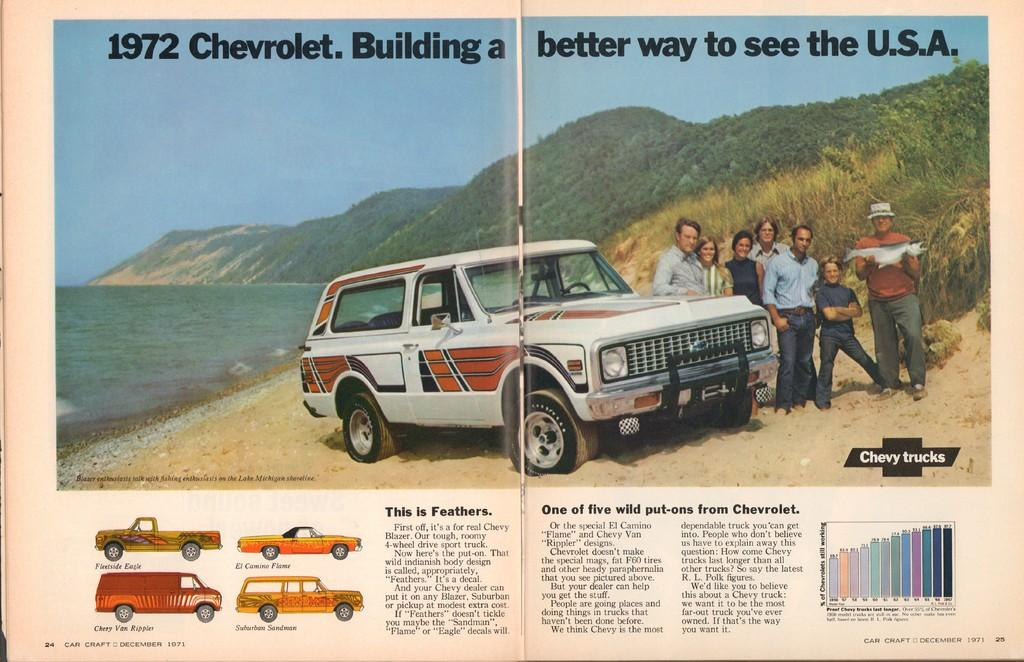What type of medium is the image part of? The image is a page from a book. What is depicted in the image on the page? There is an image of a car on the page. What is happening in front of the car in the image? People are standing in front of the car in the image. What can be seen in the distance behind the car and people? Mountains and the sea are visible in the background of the image. What type of coach can be seen in the image? There is no coach present in the image; it features a car and people standing in front of it. What scene is depicted in the image? The image is not a scene, but rather a page from a book that contains an image of a car with people standing in front of it. 